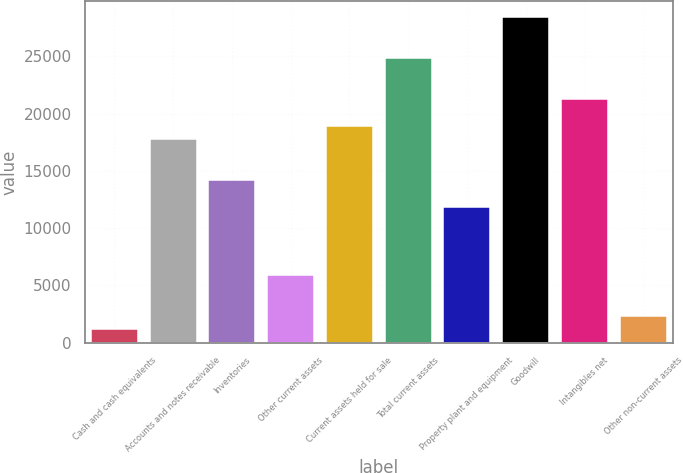<chart> <loc_0><loc_0><loc_500><loc_500><bar_chart><fcel>Cash and cash equivalents<fcel>Accounts and notes receivable<fcel>Inventories<fcel>Other current assets<fcel>Current assets held for sale<fcel>Total current assets<fcel>Property plant and equipment<fcel>Goodwill<fcel>Intangibles net<fcel>Other non-current assets<nl><fcel>1184.97<fcel>17749.3<fcel>14199.8<fcel>5917.65<fcel>18932.5<fcel>24848.4<fcel>11833.5<fcel>28397.9<fcel>21298.9<fcel>2368.14<nl></chart> 